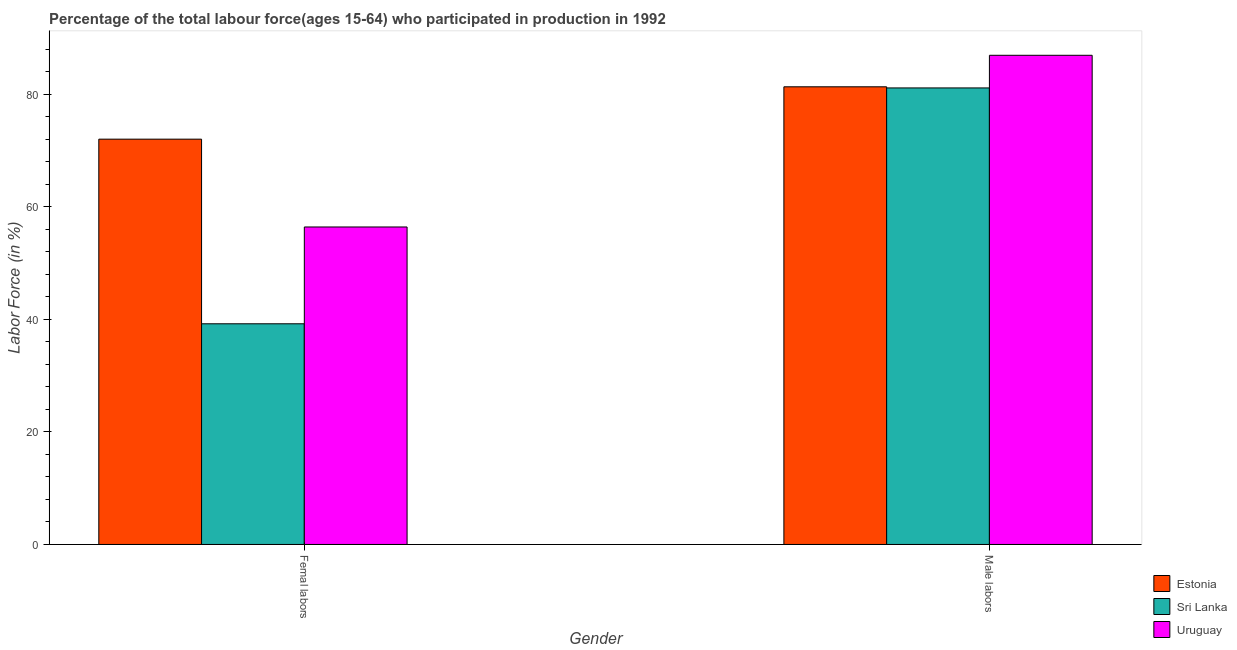How many different coloured bars are there?
Give a very brief answer. 3. How many bars are there on the 2nd tick from the left?
Your answer should be compact. 3. How many bars are there on the 1st tick from the right?
Your response must be concise. 3. What is the label of the 1st group of bars from the left?
Give a very brief answer. Femal labors. What is the percentage of female labor force in Uruguay?
Your answer should be compact. 56.4. Across all countries, what is the maximum percentage of male labour force?
Provide a succinct answer. 86.9. Across all countries, what is the minimum percentage of female labor force?
Provide a succinct answer. 39.2. In which country was the percentage of male labour force maximum?
Make the answer very short. Uruguay. In which country was the percentage of male labour force minimum?
Offer a very short reply. Sri Lanka. What is the total percentage of female labor force in the graph?
Make the answer very short. 167.6. What is the difference between the percentage of male labour force in Sri Lanka and that in Uruguay?
Provide a succinct answer. -5.8. What is the difference between the percentage of male labour force in Estonia and the percentage of female labor force in Uruguay?
Offer a terse response. 24.9. What is the average percentage of female labor force per country?
Provide a succinct answer. 55.87. What is the difference between the percentage of female labor force and percentage of male labour force in Estonia?
Ensure brevity in your answer.  -9.3. In how many countries, is the percentage of male labour force greater than 68 %?
Provide a short and direct response. 3. What is the ratio of the percentage of female labor force in Estonia to that in Uruguay?
Keep it short and to the point. 1.28. What does the 1st bar from the left in Femal labors represents?
Give a very brief answer. Estonia. What does the 3rd bar from the right in Male labors represents?
Ensure brevity in your answer.  Estonia. How many bars are there?
Your answer should be compact. 6. Are all the bars in the graph horizontal?
Offer a terse response. No. Where does the legend appear in the graph?
Offer a very short reply. Bottom right. How many legend labels are there?
Your answer should be very brief. 3. How are the legend labels stacked?
Give a very brief answer. Vertical. What is the title of the graph?
Make the answer very short. Percentage of the total labour force(ages 15-64) who participated in production in 1992. What is the label or title of the X-axis?
Give a very brief answer. Gender. What is the Labor Force (in %) of Sri Lanka in Femal labors?
Offer a terse response. 39.2. What is the Labor Force (in %) of Uruguay in Femal labors?
Provide a short and direct response. 56.4. What is the Labor Force (in %) of Estonia in Male labors?
Your answer should be very brief. 81.3. What is the Labor Force (in %) of Sri Lanka in Male labors?
Ensure brevity in your answer.  81.1. What is the Labor Force (in %) in Uruguay in Male labors?
Provide a succinct answer. 86.9. Across all Gender, what is the maximum Labor Force (in %) in Estonia?
Your answer should be very brief. 81.3. Across all Gender, what is the maximum Labor Force (in %) in Sri Lanka?
Give a very brief answer. 81.1. Across all Gender, what is the maximum Labor Force (in %) of Uruguay?
Your answer should be compact. 86.9. Across all Gender, what is the minimum Labor Force (in %) in Sri Lanka?
Your answer should be compact. 39.2. Across all Gender, what is the minimum Labor Force (in %) in Uruguay?
Your response must be concise. 56.4. What is the total Labor Force (in %) in Estonia in the graph?
Offer a terse response. 153.3. What is the total Labor Force (in %) in Sri Lanka in the graph?
Your answer should be compact. 120.3. What is the total Labor Force (in %) in Uruguay in the graph?
Keep it short and to the point. 143.3. What is the difference between the Labor Force (in %) in Estonia in Femal labors and that in Male labors?
Ensure brevity in your answer.  -9.3. What is the difference between the Labor Force (in %) of Sri Lanka in Femal labors and that in Male labors?
Offer a terse response. -41.9. What is the difference between the Labor Force (in %) in Uruguay in Femal labors and that in Male labors?
Provide a succinct answer. -30.5. What is the difference between the Labor Force (in %) of Estonia in Femal labors and the Labor Force (in %) of Sri Lanka in Male labors?
Your answer should be very brief. -9.1. What is the difference between the Labor Force (in %) of Estonia in Femal labors and the Labor Force (in %) of Uruguay in Male labors?
Offer a very short reply. -14.9. What is the difference between the Labor Force (in %) in Sri Lanka in Femal labors and the Labor Force (in %) in Uruguay in Male labors?
Ensure brevity in your answer.  -47.7. What is the average Labor Force (in %) in Estonia per Gender?
Offer a very short reply. 76.65. What is the average Labor Force (in %) in Sri Lanka per Gender?
Give a very brief answer. 60.15. What is the average Labor Force (in %) in Uruguay per Gender?
Ensure brevity in your answer.  71.65. What is the difference between the Labor Force (in %) in Estonia and Labor Force (in %) in Sri Lanka in Femal labors?
Offer a very short reply. 32.8. What is the difference between the Labor Force (in %) of Estonia and Labor Force (in %) of Uruguay in Femal labors?
Make the answer very short. 15.6. What is the difference between the Labor Force (in %) in Sri Lanka and Labor Force (in %) in Uruguay in Femal labors?
Your answer should be very brief. -17.2. What is the ratio of the Labor Force (in %) of Estonia in Femal labors to that in Male labors?
Your response must be concise. 0.89. What is the ratio of the Labor Force (in %) in Sri Lanka in Femal labors to that in Male labors?
Make the answer very short. 0.48. What is the ratio of the Labor Force (in %) in Uruguay in Femal labors to that in Male labors?
Ensure brevity in your answer.  0.65. What is the difference between the highest and the second highest Labor Force (in %) of Estonia?
Provide a short and direct response. 9.3. What is the difference between the highest and the second highest Labor Force (in %) of Sri Lanka?
Your response must be concise. 41.9. What is the difference between the highest and the second highest Labor Force (in %) in Uruguay?
Keep it short and to the point. 30.5. What is the difference between the highest and the lowest Labor Force (in %) of Sri Lanka?
Provide a short and direct response. 41.9. What is the difference between the highest and the lowest Labor Force (in %) in Uruguay?
Your response must be concise. 30.5. 